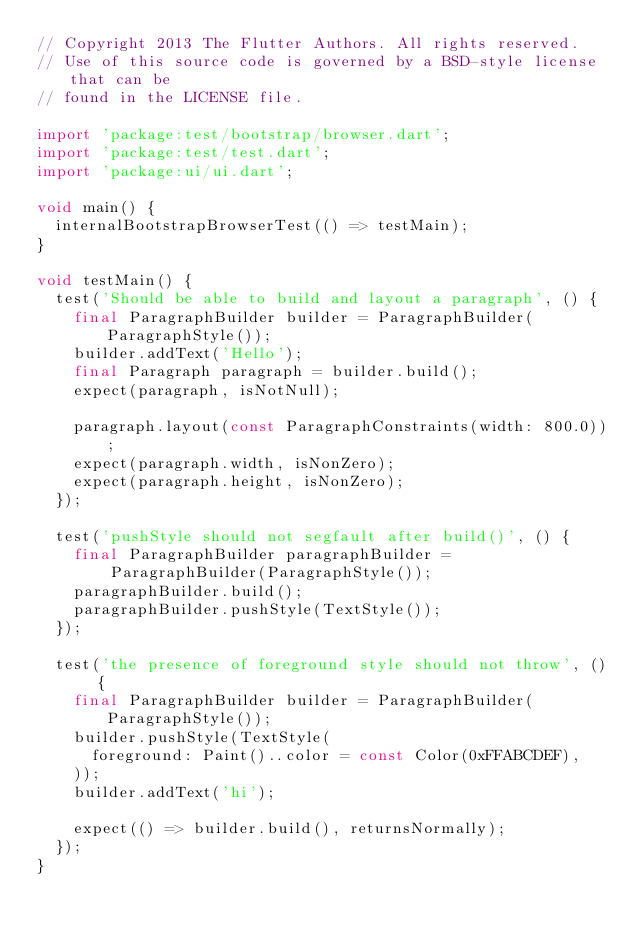Convert code to text. <code><loc_0><loc_0><loc_500><loc_500><_Dart_>// Copyright 2013 The Flutter Authors. All rights reserved.
// Use of this source code is governed by a BSD-style license that can be
// found in the LICENSE file.

import 'package:test/bootstrap/browser.dart';
import 'package:test/test.dart';
import 'package:ui/ui.dart';

void main() {
  internalBootstrapBrowserTest(() => testMain);
}

void testMain() {
  test('Should be able to build and layout a paragraph', () {
    final ParagraphBuilder builder = ParagraphBuilder(ParagraphStyle());
    builder.addText('Hello');
    final Paragraph paragraph = builder.build();
    expect(paragraph, isNotNull);

    paragraph.layout(const ParagraphConstraints(width: 800.0));
    expect(paragraph.width, isNonZero);
    expect(paragraph.height, isNonZero);
  });

  test('pushStyle should not segfault after build()', () {
    final ParagraphBuilder paragraphBuilder =
        ParagraphBuilder(ParagraphStyle());
    paragraphBuilder.build();
    paragraphBuilder.pushStyle(TextStyle());
  });

  test('the presence of foreground style should not throw', () {
    final ParagraphBuilder builder = ParagraphBuilder(ParagraphStyle());
    builder.pushStyle(TextStyle(
      foreground: Paint()..color = const Color(0xFFABCDEF),
    ));
    builder.addText('hi');

    expect(() => builder.build(), returnsNormally);
  });
}
</code> 